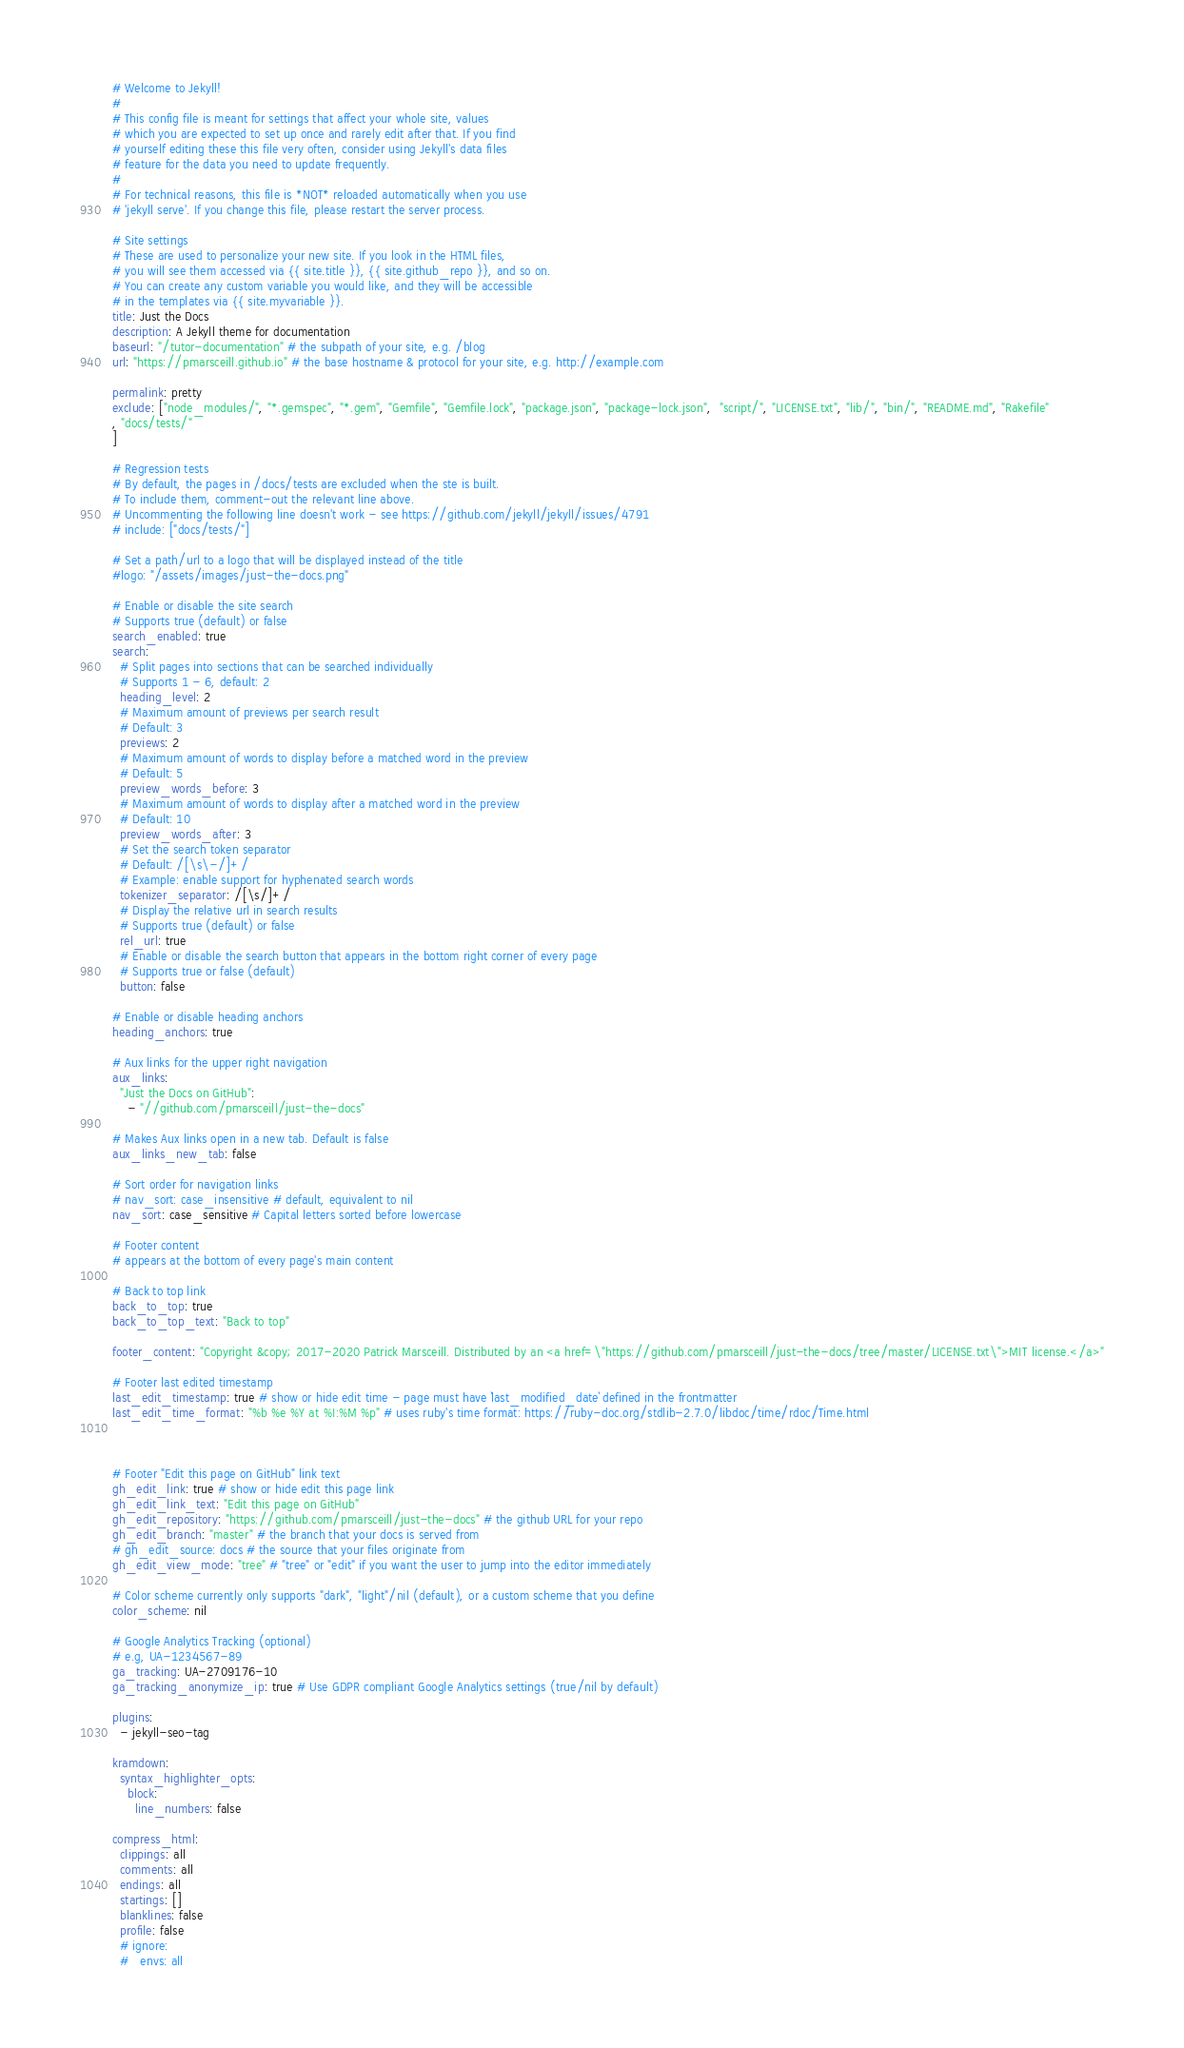Convert code to text. <code><loc_0><loc_0><loc_500><loc_500><_YAML_># Welcome to Jekyll!
#
# This config file is meant for settings that affect your whole site, values
# which you are expected to set up once and rarely edit after that. If you find
# yourself editing these this file very often, consider using Jekyll's data files
# feature for the data you need to update frequently.
#
# For technical reasons, this file is *NOT* reloaded automatically when you use
# 'jekyll serve'. If you change this file, please restart the server process.

# Site settings
# These are used to personalize your new site. If you look in the HTML files,
# you will see them accessed via {{ site.title }}, {{ site.github_repo }}, and so on.
# You can create any custom variable you would like, and they will be accessible
# in the templates via {{ site.myvariable }}.
title: Just the Docs
description: A Jekyll theme for documentation
baseurl: "/tutor-documentation" # the subpath of your site, e.g. /blog
url: "https://pmarsceill.github.io" # the base hostname & protocol for your site, e.g. http://example.com

permalink: pretty
exclude: ["node_modules/", "*.gemspec", "*.gem", "Gemfile", "Gemfile.lock", "package.json", "package-lock.json",  "script/", "LICENSE.txt", "lib/", "bin/", "README.md", "Rakefile"
, "docs/tests/"
]

# Regression tests
# By default, the pages in /docs/tests are excluded when the ste is built.
# To include them, comment-out the relevant line above.
# Uncommenting the following line doesn't work - see https://github.com/jekyll/jekyll/issues/4791
# include: ["docs/tests/"]

# Set a path/url to a logo that will be displayed instead of the title
#logo: "/assets/images/just-the-docs.png"

# Enable or disable the site search
# Supports true (default) or false
search_enabled: true
search:
  # Split pages into sections that can be searched individually
  # Supports 1 - 6, default: 2
  heading_level: 2
  # Maximum amount of previews per search result
  # Default: 3
  previews: 2
  # Maximum amount of words to display before a matched word in the preview
  # Default: 5
  preview_words_before: 3
  # Maximum amount of words to display after a matched word in the preview
  # Default: 10
  preview_words_after: 3
  # Set the search token separator
  # Default: /[\s\-/]+/
  # Example: enable support for hyphenated search words
  tokenizer_separator: /[\s/]+/
  # Display the relative url in search results
  # Supports true (default) or false
  rel_url: true
  # Enable or disable the search button that appears in the bottom right corner of every page
  # Supports true or false (default)
  button: false

# Enable or disable heading anchors
heading_anchors: true

# Aux links for the upper right navigation
aux_links:
  "Just the Docs on GitHub":
    - "//github.com/pmarsceill/just-the-docs"

# Makes Aux links open in a new tab. Default is false
aux_links_new_tab: false

# Sort order for navigation links
# nav_sort: case_insensitive # default, equivalent to nil
nav_sort: case_sensitive # Capital letters sorted before lowercase

# Footer content
# appears at the bottom of every page's main content

# Back to top link
back_to_top: true
back_to_top_text: "Back to top"

footer_content: "Copyright &copy; 2017-2020 Patrick Marsceill. Distributed by an <a href=\"https://github.com/pmarsceill/just-the-docs/tree/master/LICENSE.txt\">MIT license.</a>"

# Footer last edited timestamp
last_edit_timestamp: true # show or hide edit time - page must have `last_modified_date` defined in the frontmatter
last_edit_time_format: "%b %e %Y at %I:%M %p" # uses ruby's time format: https://ruby-doc.org/stdlib-2.7.0/libdoc/time/rdoc/Time.html



# Footer "Edit this page on GitHub" link text
gh_edit_link: true # show or hide edit this page link
gh_edit_link_text: "Edit this page on GitHub"
gh_edit_repository: "https://github.com/pmarsceill/just-the-docs" # the github URL for your repo
gh_edit_branch: "master" # the branch that your docs is served from
# gh_edit_source: docs # the source that your files originate from
gh_edit_view_mode: "tree" # "tree" or "edit" if you want the user to jump into the editor immediately

# Color scheme currently only supports "dark", "light"/nil (default), or a custom scheme that you define
color_scheme: nil

# Google Analytics Tracking (optional)
# e.g, UA-1234567-89
ga_tracking: UA-2709176-10
ga_tracking_anonymize_ip: true # Use GDPR compliant Google Analytics settings (true/nil by default)

plugins:
  - jekyll-seo-tag

kramdown:
  syntax_highlighter_opts:
    block:
      line_numbers: false

compress_html:
  clippings: all
  comments: all
  endings: all
  startings: []
  blanklines: false
  profile: false
  # ignore:
  #   envs: all
</code> 